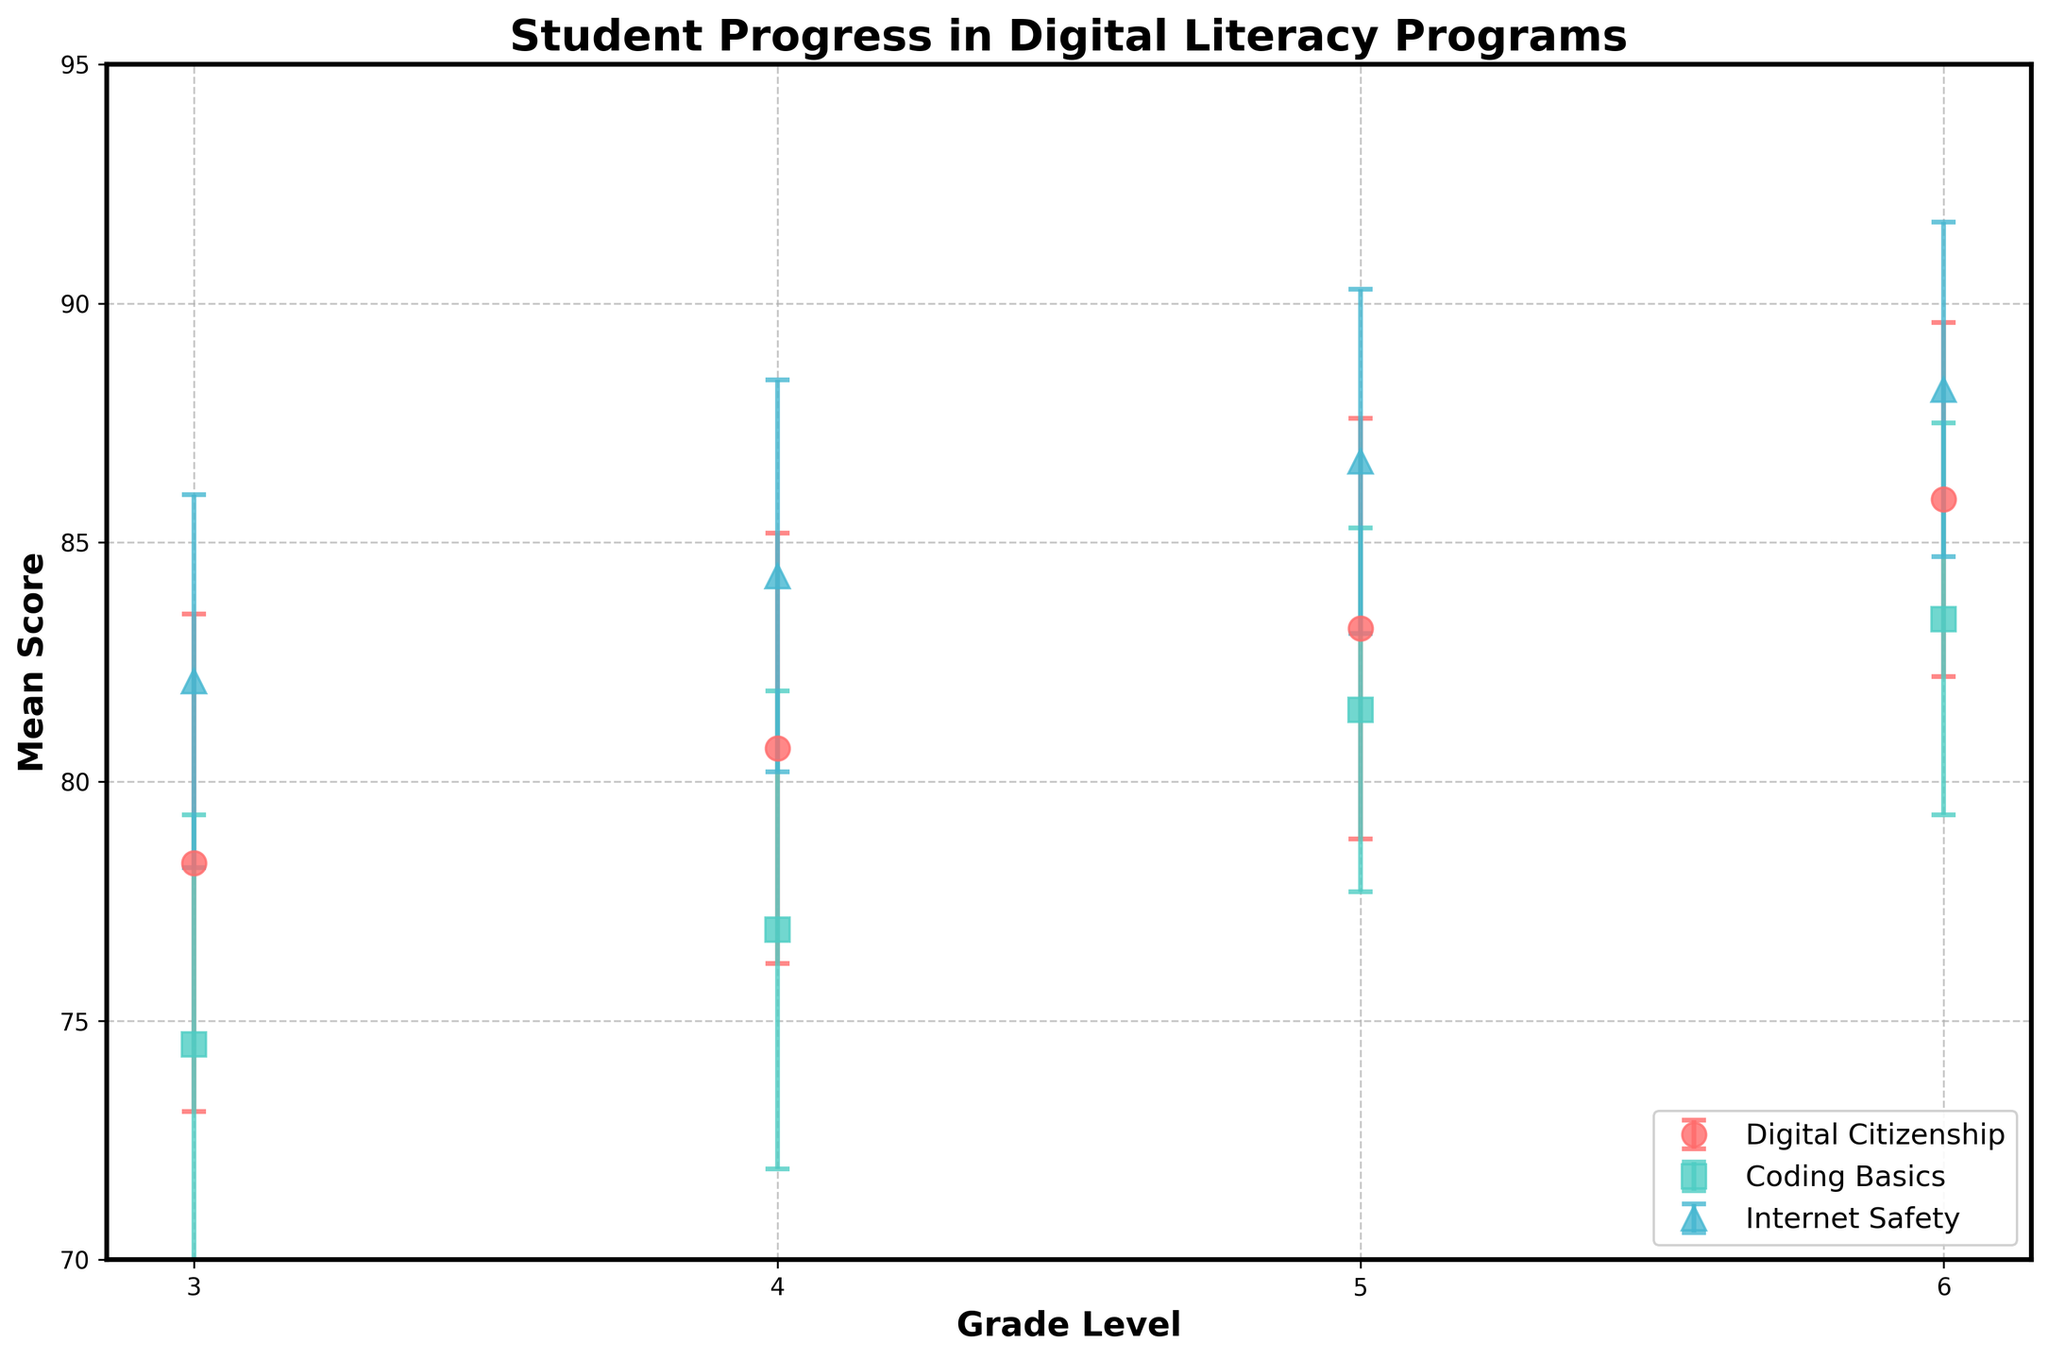What is the program with the highest mean score for 6th grade? To find the program with the highest mean score for 6th grade, we look at the data points for 6th grade and compare their mean scores. Internet Safety has the highest mean score at 88.2.
Answer: Internet Safety What is the error margin range for Coding Basics in 4th grade? To determine the error margin range, identify the error margin for Coding Basics in 4th grade. The error margin is 5.0.
Answer: 5.0 Which grade level has the lowest mean score in Digital Citizenship? To find this, we compare the mean scores of Digital Citizenship across all grade levels. 3rd grade has the lowest mean score at 78.3.
Answer: 3rd grade How does the mean score for Internet Safety in 5th grade compare to that in 4th grade? We compare the mean scores of Internet Safety in 4th and 5th grades: 84.3 (4th grade) and 86.7 (5th grade). The mean score in 5th grade is higher.
Answer: 5th grade is higher What is the difference between the highest and lowest mean scores across all programs and grades? First, identify the highest mean score (Internet Safety in 6th grade at 88.2) and the lowest mean score (Coding Basics in 3rd grade at 74.5). The difference is 88.2 - 74.5 = 13.7.
Answer: 13.7 Does Coding Basics show an increasing trend in mean score from 3rd to 6th grade? To determine if there is an increasing trend, we compare the mean scores for Coding Basics from 3rd to 6th grades: 74.5 (3rd), 76.9 (4th), 81.5 (5th), and 83.4 (6th). Yes, the scores are increasing.
Answer: Yes Which program has the smallest error margin in 3rd grade and what is the margin? Look at the error margins for all programs in 3rd grade. Internet Safety has the smallest error margin of 3.9.
Answer: Internet Safety with an error margin of 3.9 What is the average mean score of Digital Citizenship across all grades? To find the average, sum the mean scores of Digital Citizenship across all grades and divide by the number of grades: (78.3 + 80.7 + 83.2 + 85.9) / 4 = 82.03.
Answer: 82.03 Which program shows the least variability in scores (lowest average error margin)? Calculate the average error margin for each program: Digital Citizenship: (5.2 + 4.5 + 4.4 + 3.7)/4 = 4.45, Coding Basics: (4.8 + 5.0 + 3.8 + 4.1)/4 = 4.43, Internet Safety: (3.9 + 4.1 + 3.6 + 3.5)/4 = 3.78. Internet Safety has the lowest average error margin of 3.78.
Answer: Internet Safety 